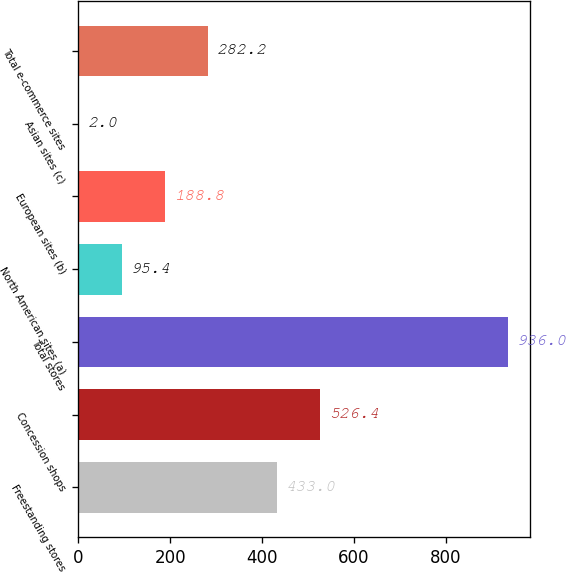Convert chart to OTSL. <chart><loc_0><loc_0><loc_500><loc_500><bar_chart><fcel>Freestanding stores<fcel>Concession shops<fcel>Total stores<fcel>North American sites (a)<fcel>European sites (b)<fcel>Asian sites (c)<fcel>Total e-commerce sites<nl><fcel>433<fcel>526.4<fcel>936<fcel>95.4<fcel>188.8<fcel>2<fcel>282.2<nl></chart> 